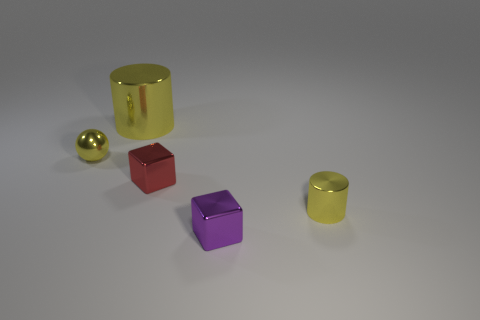Is the sphere the same color as the big metallic object?
Keep it short and to the point. Yes. How many cylinders are either big shiny things or small shiny objects?
Ensure brevity in your answer.  2. There is a small object that is in front of the red metal object and behind the purple object; what is its material?
Give a very brief answer. Metal. How many big yellow cylinders are in front of the small shiny ball?
Make the answer very short. 0. Does the tiny yellow thing on the right side of the large yellow cylinder have the same material as the tiny cube that is in front of the small yellow shiny cylinder?
Your response must be concise. Yes. How many things are things to the right of the yellow metallic sphere or small yellow shiny objects?
Make the answer very short. 5. Is the number of yellow objects behind the tiny red object less than the number of small things that are behind the small purple object?
Your answer should be very brief. Yes. How many other things are the same size as the red metallic object?
Your answer should be very brief. 3. How many objects are yellow objects right of the yellow shiny sphere or yellow metallic objects left of the purple metal cube?
Offer a terse response. 3. What color is the tiny sphere?
Offer a terse response. Yellow. 